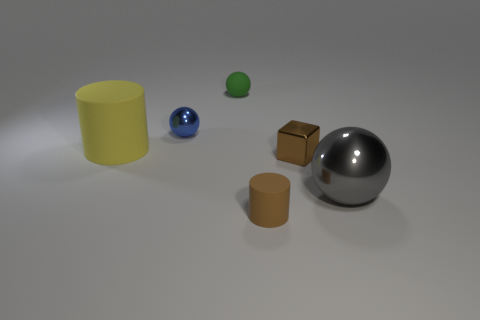Subtract all cyan spheres. Subtract all yellow blocks. How many spheres are left? 3 Add 1 shiny blocks. How many objects exist? 7 Subtract all blocks. How many objects are left? 5 Add 6 small metallic things. How many small metallic things are left? 8 Add 1 gray metal things. How many gray metal things exist? 2 Subtract 0 brown balls. How many objects are left? 6 Subtract all big gray metal cylinders. Subtract all matte balls. How many objects are left? 5 